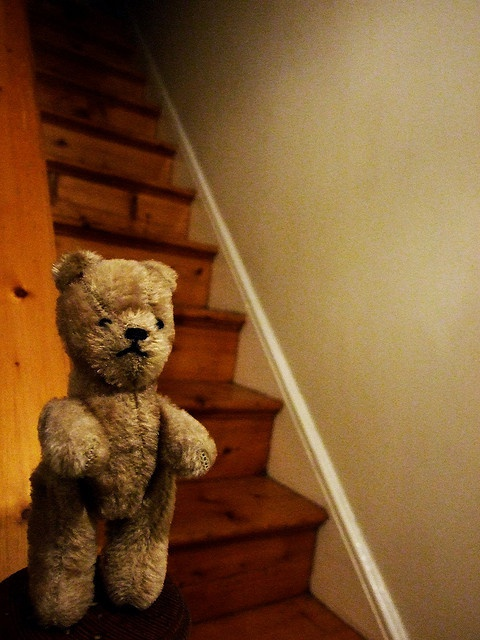Describe the objects in this image and their specific colors. I can see a teddy bear in maroon, black, and olive tones in this image. 